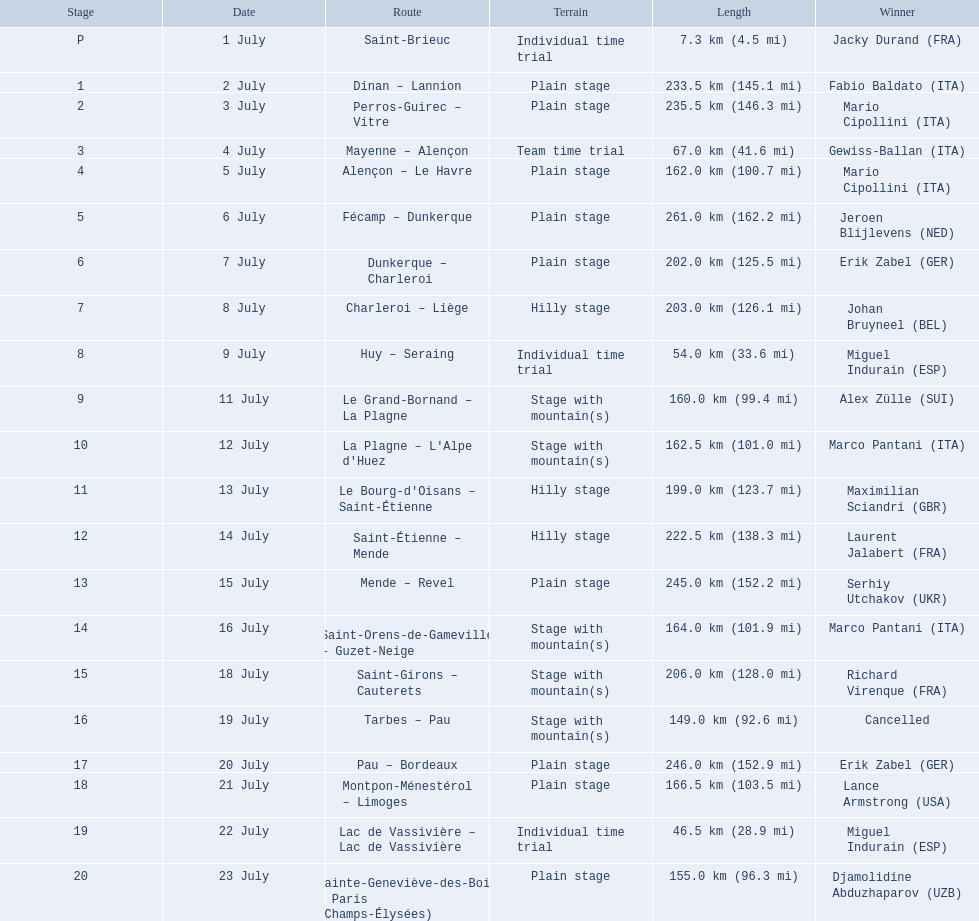Can you provide the dates? 1 July, 2 July, 3 July, 4 July, 5 July, 6 July, 7 July, 8 July, 9 July, 11 July, 12 July, 13 July, 14 July, 15 July, 16 July, 18 July, 19 July, 20 July, 21 July, 22 July, 23 July. What is the duration on the 8th of july? 203.0 km (126.1 mi). 